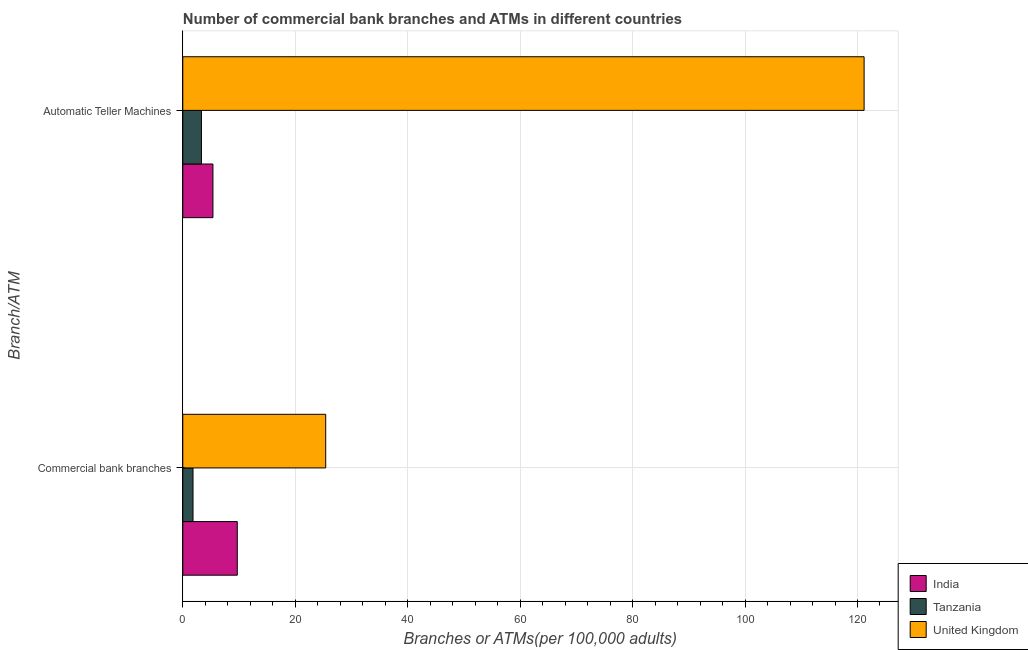How many different coloured bars are there?
Offer a very short reply. 3. What is the label of the 2nd group of bars from the top?
Provide a succinct answer. Commercial bank branches. What is the number of commercal bank branches in United Kingdom?
Ensure brevity in your answer.  25.42. Across all countries, what is the maximum number of atms?
Offer a very short reply. 121.18. Across all countries, what is the minimum number of commercal bank branches?
Offer a very short reply. 1.82. In which country was the number of commercal bank branches maximum?
Provide a short and direct response. United Kingdom. In which country was the number of commercal bank branches minimum?
Make the answer very short. Tanzania. What is the total number of atms in the graph?
Keep it short and to the point. 129.85. What is the difference between the number of atms in United Kingdom and that in India?
Make the answer very short. 115.82. What is the difference between the number of commercal bank branches in India and the number of atms in United Kingdom?
Keep it short and to the point. -111.49. What is the average number of commercal bank branches per country?
Offer a terse response. 12.31. What is the difference between the number of atms and number of commercal bank branches in India?
Provide a short and direct response. -4.33. What is the ratio of the number of commercal bank branches in Tanzania to that in India?
Offer a very short reply. 0.19. Is the number of commercal bank branches in United Kingdom less than that in India?
Give a very brief answer. No. In how many countries, is the number of commercal bank branches greater than the average number of commercal bank branches taken over all countries?
Your answer should be compact. 1. What does the 3rd bar from the bottom in Automatic Teller Machines represents?
Ensure brevity in your answer.  United Kingdom. Are all the bars in the graph horizontal?
Give a very brief answer. Yes. What is the difference between two consecutive major ticks on the X-axis?
Provide a succinct answer. 20. Does the graph contain grids?
Keep it short and to the point. Yes. Where does the legend appear in the graph?
Your answer should be very brief. Bottom right. How many legend labels are there?
Provide a succinct answer. 3. How are the legend labels stacked?
Keep it short and to the point. Vertical. What is the title of the graph?
Offer a terse response. Number of commercial bank branches and ATMs in different countries. Does "Guinea" appear as one of the legend labels in the graph?
Give a very brief answer. No. What is the label or title of the X-axis?
Offer a terse response. Branches or ATMs(per 100,0 adults). What is the label or title of the Y-axis?
Your answer should be compact. Branch/ATM. What is the Branches or ATMs(per 100,000 adults) in India in Commercial bank branches?
Make the answer very short. 9.69. What is the Branches or ATMs(per 100,000 adults) in Tanzania in Commercial bank branches?
Provide a succinct answer. 1.82. What is the Branches or ATMs(per 100,000 adults) in United Kingdom in Commercial bank branches?
Make the answer very short. 25.42. What is the Branches or ATMs(per 100,000 adults) of India in Automatic Teller Machines?
Your answer should be very brief. 5.36. What is the Branches or ATMs(per 100,000 adults) in Tanzania in Automatic Teller Machines?
Your answer should be very brief. 3.31. What is the Branches or ATMs(per 100,000 adults) in United Kingdom in Automatic Teller Machines?
Your answer should be compact. 121.18. Across all Branch/ATM, what is the maximum Branches or ATMs(per 100,000 adults) of India?
Keep it short and to the point. 9.69. Across all Branch/ATM, what is the maximum Branches or ATMs(per 100,000 adults) of Tanzania?
Your answer should be compact. 3.31. Across all Branch/ATM, what is the maximum Branches or ATMs(per 100,000 adults) of United Kingdom?
Your answer should be compact. 121.18. Across all Branch/ATM, what is the minimum Branches or ATMs(per 100,000 adults) in India?
Your answer should be compact. 5.36. Across all Branch/ATM, what is the minimum Branches or ATMs(per 100,000 adults) of Tanzania?
Provide a succinct answer. 1.82. Across all Branch/ATM, what is the minimum Branches or ATMs(per 100,000 adults) in United Kingdom?
Offer a terse response. 25.42. What is the total Branches or ATMs(per 100,000 adults) in India in the graph?
Your answer should be very brief. 15.05. What is the total Branches or ATMs(per 100,000 adults) in Tanzania in the graph?
Give a very brief answer. 5.13. What is the total Branches or ATMs(per 100,000 adults) in United Kingdom in the graph?
Your response must be concise. 146.59. What is the difference between the Branches or ATMs(per 100,000 adults) in India in Commercial bank branches and that in Automatic Teller Machines?
Keep it short and to the point. 4.33. What is the difference between the Branches or ATMs(per 100,000 adults) of Tanzania in Commercial bank branches and that in Automatic Teller Machines?
Offer a terse response. -1.49. What is the difference between the Branches or ATMs(per 100,000 adults) in United Kingdom in Commercial bank branches and that in Automatic Teller Machines?
Your answer should be very brief. -95.76. What is the difference between the Branches or ATMs(per 100,000 adults) of India in Commercial bank branches and the Branches or ATMs(per 100,000 adults) of Tanzania in Automatic Teller Machines?
Provide a short and direct response. 6.38. What is the difference between the Branches or ATMs(per 100,000 adults) of India in Commercial bank branches and the Branches or ATMs(per 100,000 adults) of United Kingdom in Automatic Teller Machines?
Provide a short and direct response. -111.49. What is the difference between the Branches or ATMs(per 100,000 adults) of Tanzania in Commercial bank branches and the Branches or ATMs(per 100,000 adults) of United Kingdom in Automatic Teller Machines?
Your answer should be compact. -119.36. What is the average Branches or ATMs(per 100,000 adults) of India per Branch/ATM?
Provide a short and direct response. 7.53. What is the average Branches or ATMs(per 100,000 adults) of Tanzania per Branch/ATM?
Make the answer very short. 2.57. What is the average Branches or ATMs(per 100,000 adults) in United Kingdom per Branch/ATM?
Your answer should be very brief. 73.3. What is the difference between the Branches or ATMs(per 100,000 adults) in India and Branches or ATMs(per 100,000 adults) in Tanzania in Commercial bank branches?
Keep it short and to the point. 7.87. What is the difference between the Branches or ATMs(per 100,000 adults) of India and Branches or ATMs(per 100,000 adults) of United Kingdom in Commercial bank branches?
Ensure brevity in your answer.  -15.73. What is the difference between the Branches or ATMs(per 100,000 adults) of Tanzania and Branches or ATMs(per 100,000 adults) of United Kingdom in Commercial bank branches?
Your answer should be very brief. -23.6. What is the difference between the Branches or ATMs(per 100,000 adults) of India and Branches or ATMs(per 100,000 adults) of Tanzania in Automatic Teller Machines?
Offer a terse response. 2.05. What is the difference between the Branches or ATMs(per 100,000 adults) in India and Branches or ATMs(per 100,000 adults) in United Kingdom in Automatic Teller Machines?
Provide a succinct answer. -115.82. What is the difference between the Branches or ATMs(per 100,000 adults) in Tanzania and Branches or ATMs(per 100,000 adults) in United Kingdom in Automatic Teller Machines?
Provide a succinct answer. -117.86. What is the ratio of the Branches or ATMs(per 100,000 adults) in India in Commercial bank branches to that in Automatic Teller Machines?
Your response must be concise. 1.81. What is the ratio of the Branches or ATMs(per 100,000 adults) in Tanzania in Commercial bank branches to that in Automatic Teller Machines?
Make the answer very short. 0.55. What is the ratio of the Branches or ATMs(per 100,000 adults) in United Kingdom in Commercial bank branches to that in Automatic Teller Machines?
Your response must be concise. 0.21. What is the difference between the highest and the second highest Branches or ATMs(per 100,000 adults) in India?
Provide a short and direct response. 4.33. What is the difference between the highest and the second highest Branches or ATMs(per 100,000 adults) in Tanzania?
Offer a very short reply. 1.49. What is the difference between the highest and the second highest Branches or ATMs(per 100,000 adults) of United Kingdom?
Provide a succinct answer. 95.76. What is the difference between the highest and the lowest Branches or ATMs(per 100,000 adults) in India?
Your answer should be compact. 4.33. What is the difference between the highest and the lowest Branches or ATMs(per 100,000 adults) of Tanzania?
Offer a very short reply. 1.49. What is the difference between the highest and the lowest Branches or ATMs(per 100,000 adults) of United Kingdom?
Your response must be concise. 95.76. 